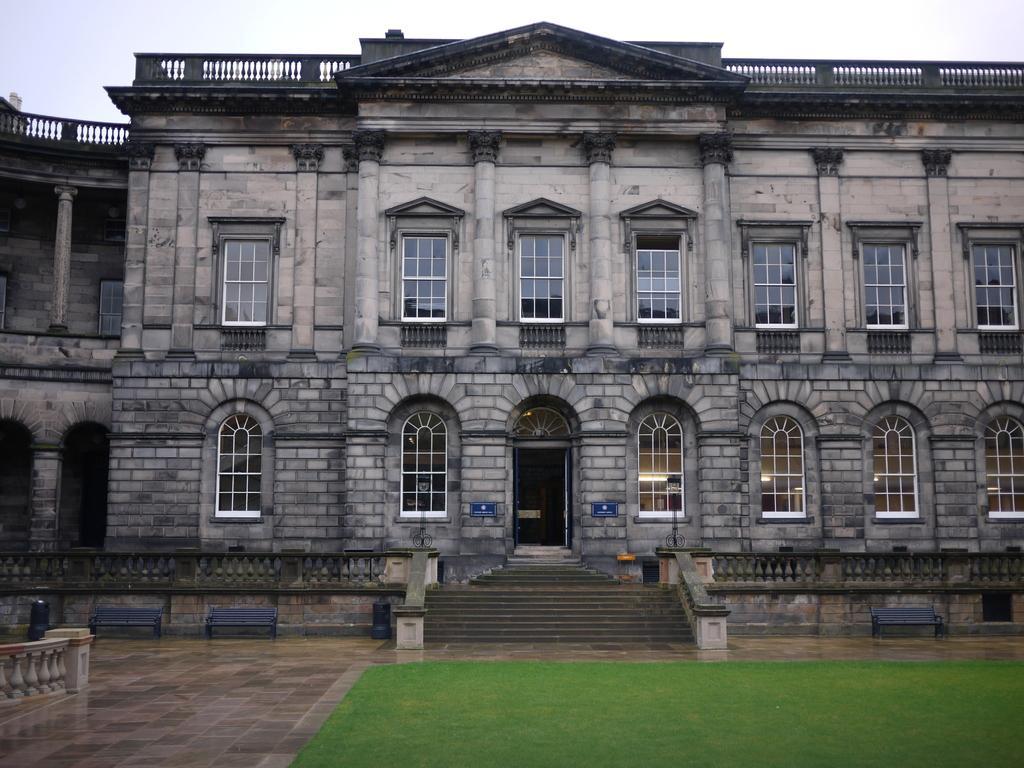Please provide a concise description of this image. In this image, I can see a building with the windows, a door and pillars. These are the stairs. I can see the benches. At the bottom of the image, I can see the grass. This is the sky. This looks like a pathway. 